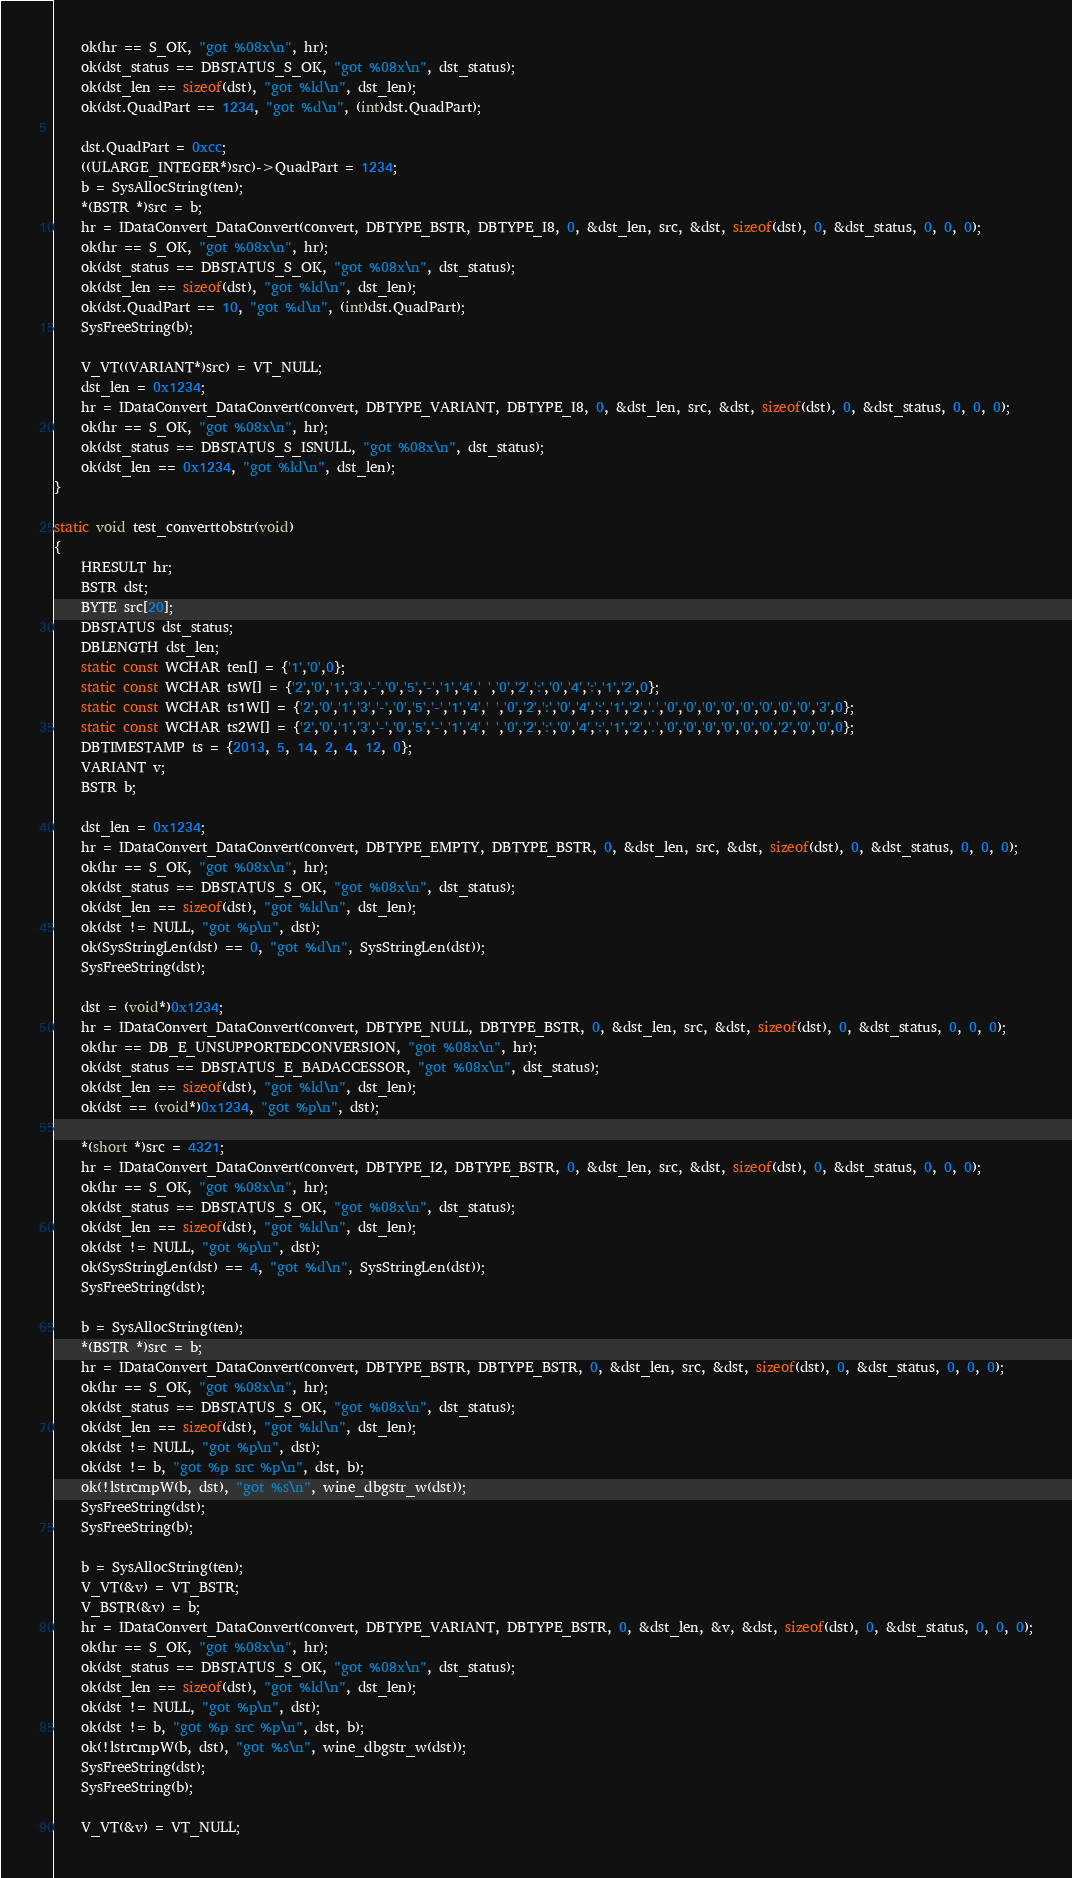Convert code to text. <code><loc_0><loc_0><loc_500><loc_500><_C_>    ok(hr == S_OK, "got %08x\n", hr);
    ok(dst_status == DBSTATUS_S_OK, "got %08x\n", dst_status);
    ok(dst_len == sizeof(dst), "got %ld\n", dst_len);
    ok(dst.QuadPart == 1234, "got %d\n", (int)dst.QuadPart);

    dst.QuadPart = 0xcc;
    ((ULARGE_INTEGER*)src)->QuadPart = 1234;
    b = SysAllocString(ten);
    *(BSTR *)src = b;
    hr = IDataConvert_DataConvert(convert, DBTYPE_BSTR, DBTYPE_I8, 0, &dst_len, src, &dst, sizeof(dst), 0, &dst_status, 0, 0, 0);
    ok(hr == S_OK, "got %08x\n", hr);
    ok(dst_status == DBSTATUS_S_OK, "got %08x\n", dst_status);
    ok(dst_len == sizeof(dst), "got %ld\n", dst_len);
    ok(dst.QuadPart == 10, "got %d\n", (int)dst.QuadPart);
    SysFreeString(b);

    V_VT((VARIANT*)src) = VT_NULL;
    dst_len = 0x1234;
    hr = IDataConvert_DataConvert(convert, DBTYPE_VARIANT, DBTYPE_I8, 0, &dst_len, src, &dst, sizeof(dst), 0, &dst_status, 0, 0, 0);
    ok(hr == S_OK, "got %08x\n", hr);
    ok(dst_status == DBSTATUS_S_ISNULL, "got %08x\n", dst_status);
    ok(dst_len == 0x1234, "got %ld\n", dst_len);
}

static void test_converttobstr(void)
{
    HRESULT hr;
    BSTR dst;
    BYTE src[20];
    DBSTATUS dst_status;
    DBLENGTH dst_len;
    static const WCHAR ten[] = {'1','0',0};
    static const WCHAR tsW[] = {'2','0','1','3','-','0','5','-','1','4',' ','0','2',':','0','4',':','1','2',0};
    static const WCHAR ts1W[] = {'2','0','1','3','-','0','5','-','1','4',' ','0','2',':','0','4',':','1','2','.','0','0','0','0','0','0','0','0','3',0};
    static const WCHAR ts2W[] = {'2','0','1','3','-','0','5','-','1','4',' ','0','2',':','0','4',':','1','2','.','0','0','0','0','0','0','2','0','0',0};
    DBTIMESTAMP ts = {2013, 5, 14, 2, 4, 12, 0};
    VARIANT v;
    BSTR b;

    dst_len = 0x1234;
    hr = IDataConvert_DataConvert(convert, DBTYPE_EMPTY, DBTYPE_BSTR, 0, &dst_len, src, &dst, sizeof(dst), 0, &dst_status, 0, 0, 0);
    ok(hr == S_OK, "got %08x\n", hr);
    ok(dst_status == DBSTATUS_S_OK, "got %08x\n", dst_status);
    ok(dst_len == sizeof(dst), "got %ld\n", dst_len);
    ok(dst != NULL, "got %p\n", dst);
    ok(SysStringLen(dst) == 0, "got %d\n", SysStringLen(dst));
    SysFreeString(dst);

    dst = (void*)0x1234;
    hr = IDataConvert_DataConvert(convert, DBTYPE_NULL, DBTYPE_BSTR, 0, &dst_len, src, &dst, sizeof(dst), 0, &dst_status, 0, 0, 0);
    ok(hr == DB_E_UNSUPPORTEDCONVERSION, "got %08x\n", hr);
    ok(dst_status == DBSTATUS_E_BADACCESSOR, "got %08x\n", dst_status);
    ok(dst_len == sizeof(dst), "got %ld\n", dst_len);
    ok(dst == (void*)0x1234, "got %p\n", dst);

    *(short *)src = 4321;
    hr = IDataConvert_DataConvert(convert, DBTYPE_I2, DBTYPE_BSTR, 0, &dst_len, src, &dst, sizeof(dst), 0, &dst_status, 0, 0, 0);
    ok(hr == S_OK, "got %08x\n", hr);
    ok(dst_status == DBSTATUS_S_OK, "got %08x\n", dst_status);
    ok(dst_len == sizeof(dst), "got %ld\n", dst_len);
    ok(dst != NULL, "got %p\n", dst);
    ok(SysStringLen(dst) == 4, "got %d\n", SysStringLen(dst));
    SysFreeString(dst);

    b = SysAllocString(ten);
    *(BSTR *)src = b;
    hr = IDataConvert_DataConvert(convert, DBTYPE_BSTR, DBTYPE_BSTR, 0, &dst_len, src, &dst, sizeof(dst), 0, &dst_status, 0, 0, 0);
    ok(hr == S_OK, "got %08x\n", hr);
    ok(dst_status == DBSTATUS_S_OK, "got %08x\n", dst_status);
    ok(dst_len == sizeof(dst), "got %ld\n", dst_len);
    ok(dst != NULL, "got %p\n", dst);
    ok(dst != b, "got %p src %p\n", dst, b);
    ok(!lstrcmpW(b, dst), "got %s\n", wine_dbgstr_w(dst));
    SysFreeString(dst);
    SysFreeString(b);

    b = SysAllocString(ten);
    V_VT(&v) = VT_BSTR;
    V_BSTR(&v) = b;
    hr = IDataConvert_DataConvert(convert, DBTYPE_VARIANT, DBTYPE_BSTR, 0, &dst_len, &v, &dst, sizeof(dst), 0, &dst_status, 0, 0, 0);
    ok(hr == S_OK, "got %08x\n", hr);
    ok(dst_status == DBSTATUS_S_OK, "got %08x\n", dst_status);
    ok(dst_len == sizeof(dst), "got %ld\n", dst_len);
    ok(dst != NULL, "got %p\n", dst);
    ok(dst != b, "got %p src %p\n", dst, b);
    ok(!lstrcmpW(b, dst), "got %s\n", wine_dbgstr_w(dst));
    SysFreeString(dst);
    SysFreeString(b);

    V_VT(&v) = VT_NULL;</code> 